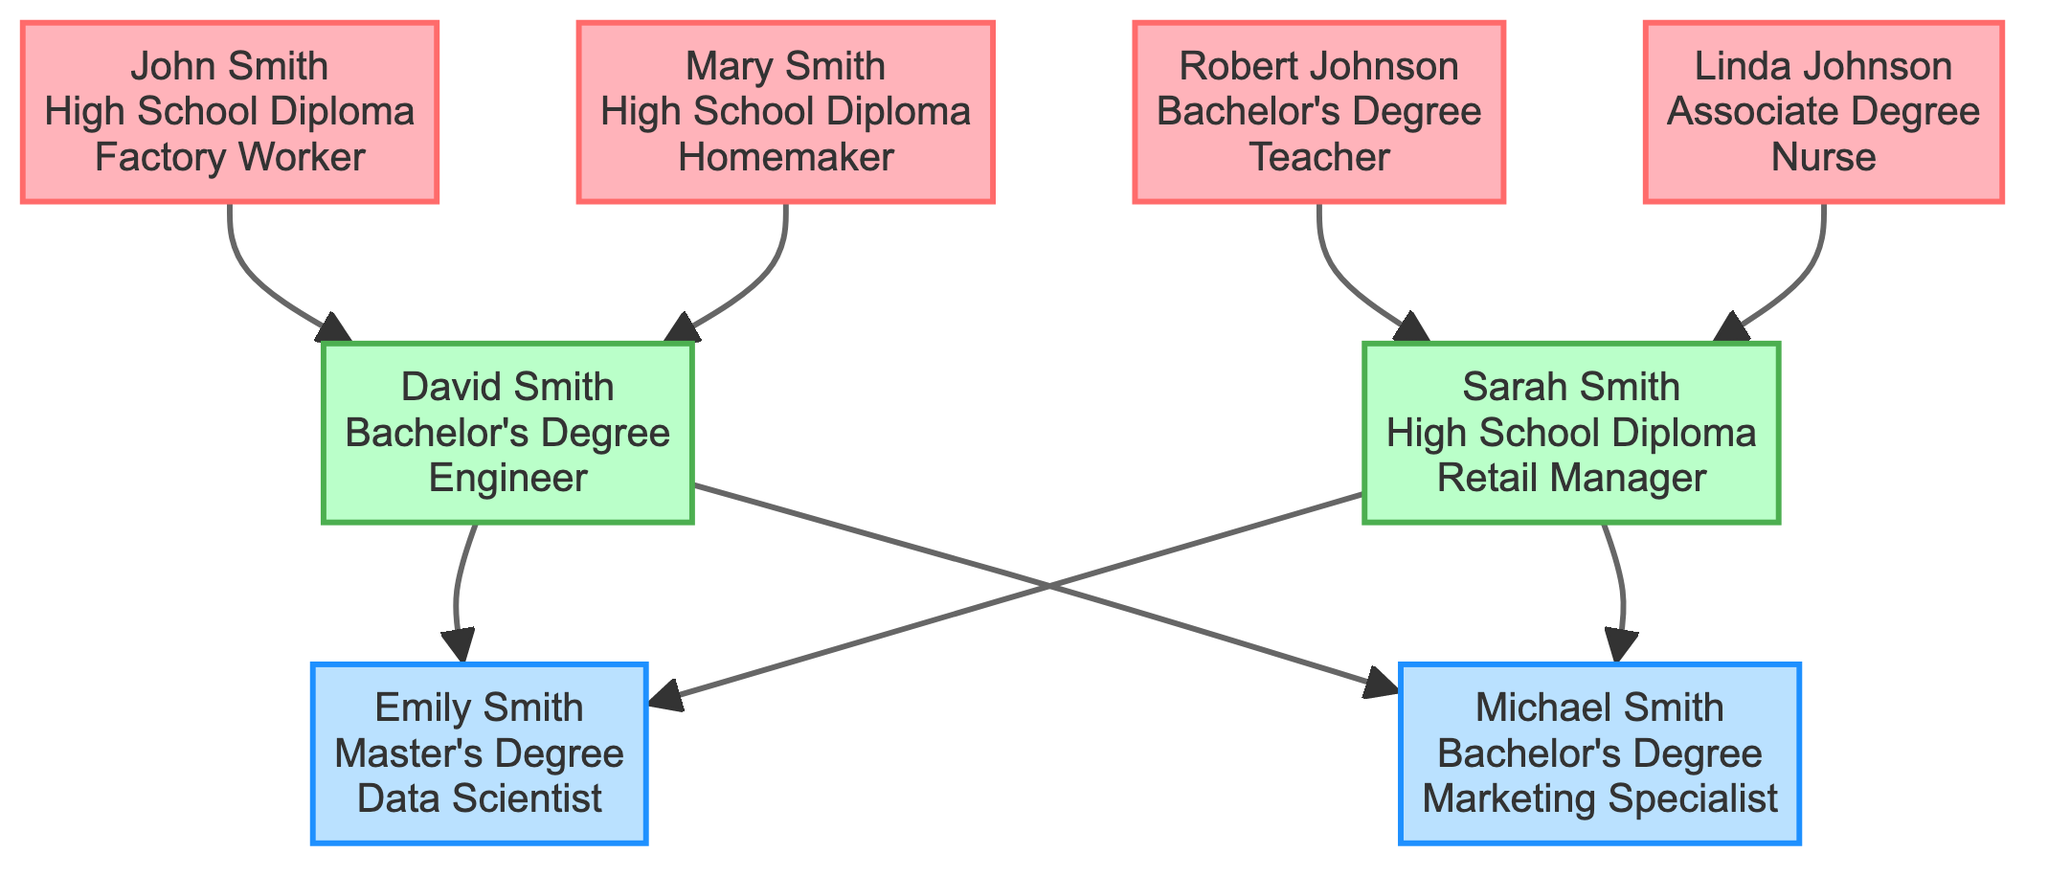What is the highest level of education attained by Emily Smith? In the diagram, the education level for Emily Smith is specified to be a Master's Degree.
Answer: Master's Degree Who are the parents of Michael Smith? The diagram shows that Michael Smith has David Smith and Sarah Smith as parents, indicated by the lines connecting them.
Answer: David Smith and Sarah Smith How many grandparents are represented in the family tree? The diagram displays a total of four grandparents: John Smith, Mary Smith, Robert Johnson, and Linda Johnson.
Answer: 4 What is the career of David Smith? According to the diagram, David Smith’s career is listed as an Engineer.
Answer: Engineer Which grandparent has the highest educational attainment? In the diagram, Robert Johnson holds the highest educational attainment with a Bachelor's Degree, compared to the others with lower qualifications.
Answer: Bachelor's Degree How many children are there in this family tree? The diagram indicates there are two children, Emily Smith and Michael Smith, shown at the child level.
Answer: 2 What is Sarah Smith’s level of education? The level of education listed for Sarah Smith in the diagram is a High School Diploma.
Answer: High School Diploma Which career path is associated with Linda Johnson? Linda Johnson is identified in the diagram as having a career as a Nurse.
Answer: Nurse How many generations are represented in this family tree? The diagram contains three generations: grandparents, parents, and children.
Answer: 3 